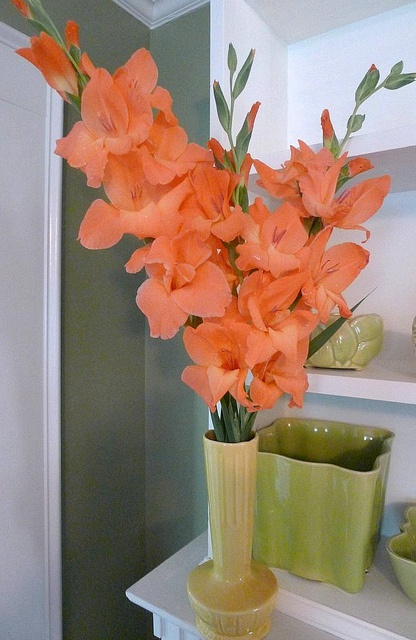Describe the objects in this image and their specific colors. I can see vase in gray and olive tones, vase in gray, tan, and olive tones, and vase in gray, tan, olive, and darkgreen tones in this image. 